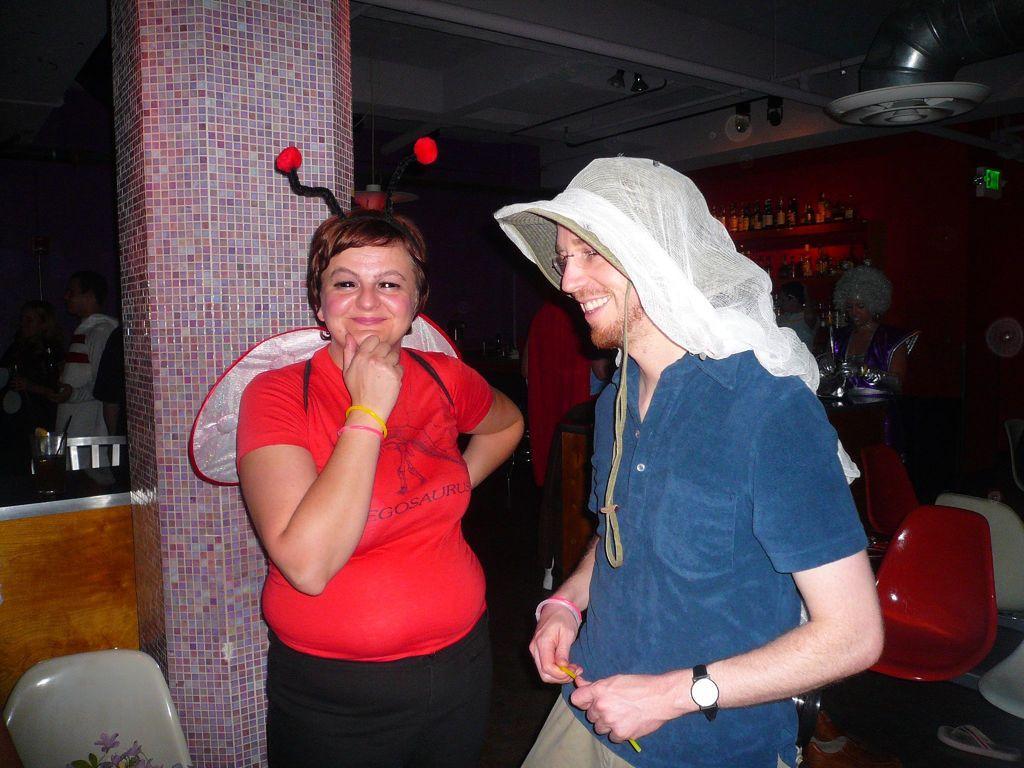Please provide a concise description of this image. In this image I can see one woman and one man. The woman is wearing red color t-shirt and the man is wearing blue color t-shirt. Just at the back of the woman there is a pillar. This is an image clicked inside the room. On the right and left side of the image I can see some chairs. In the background there is a woman standing, at the back of her few bottles are arranged in a rack. 